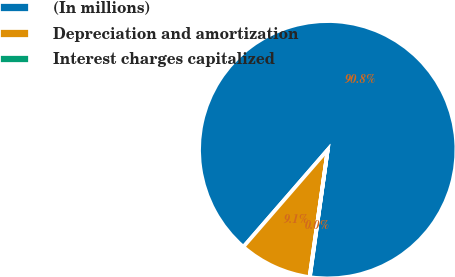<chart> <loc_0><loc_0><loc_500><loc_500><pie_chart><fcel>(In millions)<fcel>Depreciation and amortization<fcel>Interest charges capitalized<nl><fcel>90.85%<fcel>9.12%<fcel>0.04%<nl></chart> 